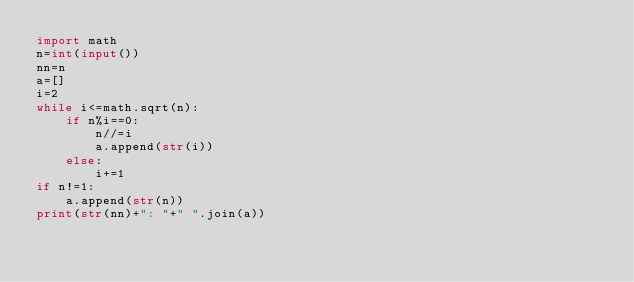Convert code to text. <code><loc_0><loc_0><loc_500><loc_500><_Python_>import math
n=int(input())
nn=n
a=[]
i=2
while i<=math.sqrt(n):
    if n%i==0:
        n//=i
        a.append(str(i))
    else:
        i+=1
if n!=1:
    a.append(str(n))
print(str(nn)+": "+" ".join(a))
</code> 